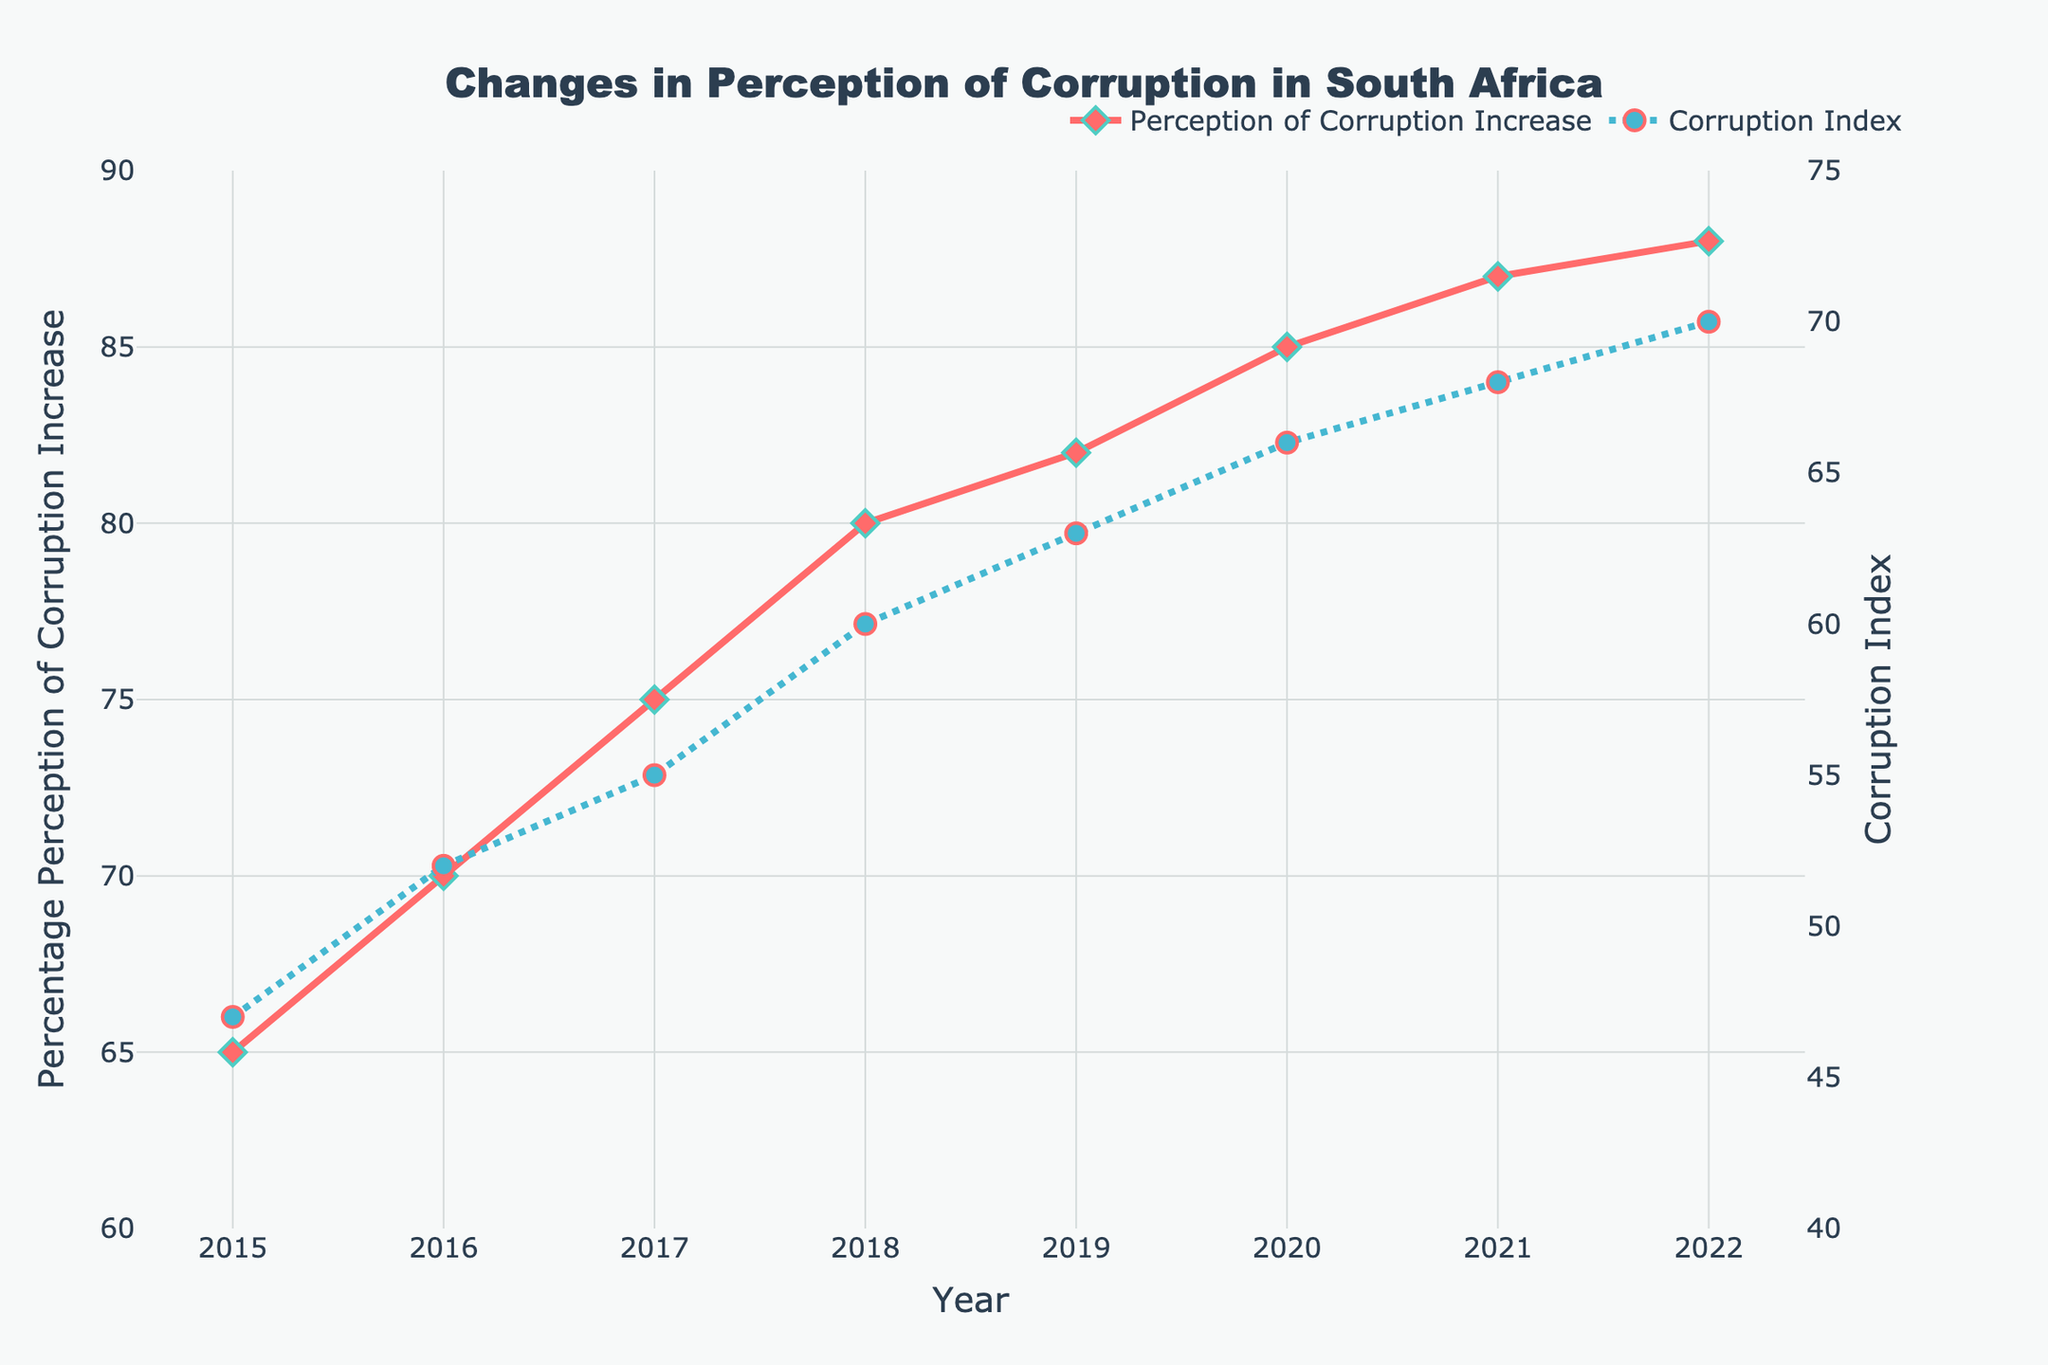What is the title of the figure? The title is prominently placed at the top center of the figure. It is designed to give a summary of what the plot is about.
Answer: Changes in Perception of Corruption in South Africa How many data points are shown for the Perception of Corruption Increase trend? To find this, you need to count the number of markers (diamonds) on the Perception of Corruption Increase line in the plot.
Answer: 8 What is the Percentage Perception of Corruption Increase in 2022? Look at the Perception of Corruption Increase line (marked with diamonds) at the year 2022 on the x-axis to find this value.
Answer: 88 How does the Corruption Index in 2020 compare to 2015? Identify the Corruption Index values for both years on the plot and find the difference. In 2020, the index is 66, and in 2015, it is 47. Subtract 47 from 66 to find the difference.
Answer: 19 units higher in 2020 During which year(s) is the overlap between the Perception of Corruption Increase and Corruption Index the closest? This requires identifying the years where the two lines are closest. Visually inspecting the plot, you can see the years 2021 and 2022 have the lines closest.
Answer: 2021 and 2022 What is the range of the Corruption Index values shown in the plot? The range is found by subtracting the minimum value from the maximum value in the Corruption Index series. The maximum is 70 (in 2022) and the minimum is 47 (in 2015).
Answer: 23 Is there any year where the Percentage Perception of Corruption Increase is the same as the Corruption Index? Look for any intersection points between the Perception of Corruption Increase line and the Corruption Index line on the plot. There are none.
Answer: No What is the average Percentage Perception of Corruption Increase across all the years shown? Sum all the Percentage Perception of Corruption Increase values and divide by the number of years (8). That is (65 + 70 + 75 + 80 + 82 + 85 + 87 + 88) / 8.
Answer: 79.125 Between which consecutive years does the Corruption Index show the highest increase? Calculate the difference in the Corruption Index values for each pair of consecutive years and identify the pair with the largest difference. Highest difference is between 2017 (55) and 2018 (60), difference of 5.
Answer: Between 2017 and 2018 